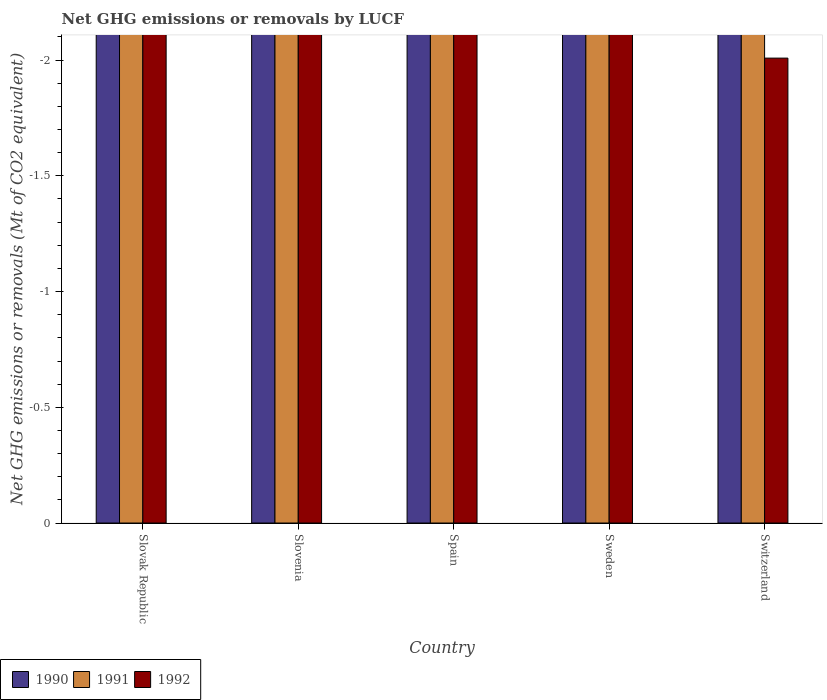Are the number of bars on each tick of the X-axis equal?
Make the answer very short. Yes. How many bars are there on the 3rd tick from the left?
Offer a very short reply. 0. How many bars are there on the 4th tick from the right?
Ensure brevity in your answer.  0. Across all countries, what is the minimum net GHG emissions or removals by LUCF in 1990?
Ensure brevity in your answer.  0. What is the average net GHG emissions or removals by LUCF in 1991 per country?
Provide a succinct answer. 0. In how many countries, is the net GHG emissions or removals by LUCF in 1991 greater than -1.2 Mt?
Offer a terse response. 0. Is it the case that in every country, the sum of the net GHG emissions or removals by LUCF in 1990 and net GHG emissions or removals by LUCF in 1992 is greater than the net GHG emissions or removals by LUCF in 1991?
Provide a short and direct response. No. How many bars are there?
Ensure brevity in your answer.  0. Does the graph contain any zero values?
Your answer should be compact. Yes. Does the graph contain grids?
Ensure brevity in your answer.  No. How many legend labels are there?
Your answer should be compact. 3. What is the title of the graph?
Ensure brevity in your answer.  Net GHG emissions or removals by LUCF. Does "2001" appear as one of the legend labels in the graph?
Offer a very short reply. No. What is the label or title of the Y-axis?
Your answer should be compact. Net GHG emissions or removals (Mt of CO2 equivalent). What is the Net GHG emissions or removals (Mt of CO2 equivalent) of 1990 in Slovak Republic?
Give a very brief answer. 0. What is the Net GHG emissions or removals (Mt of CO2 equivalent) in 1991 in Slovak Republic?
Ensure brevity in your answer.  0. What is the Net GHG emissions or removals (Mt of CO2 equivalent) of 1990 in Spain?
Offer a very short reply. 0. What is the Net GHG emissions or removals (Mt of CO2 equivalent) of 1991 in Spain?
Your answer should be compact. 0. What is the Net GHG emissions or removals (Mt of CO2 equivalent) in 1990 in Sweden?
Your response must be concise. 0. What is the Net GHG emissions or removals (Mt of CO2 equivalent) of 1990 in Switzerland?
Provide a succinct answer. 0. What is the Net GHG emissions or removals (Mt of CO2 equivalent) of 1991 in Switzerland?
Ensure brevity in your answer.  0. What is the Net GHG emissions or removals (Mt of CO2 equivalent) of 1992 in Switzerland?
Your response must be concise. 0. What is the total Net GHG emissions or removals (Mt of CO2 equivalent) in 1991 in the graph?
Give a very brief answer. 0. What is the total Net GHG emissions or removals (Mt of CO2 equivalent) in 1992 in the graph?
Your response must be concise. 0. 